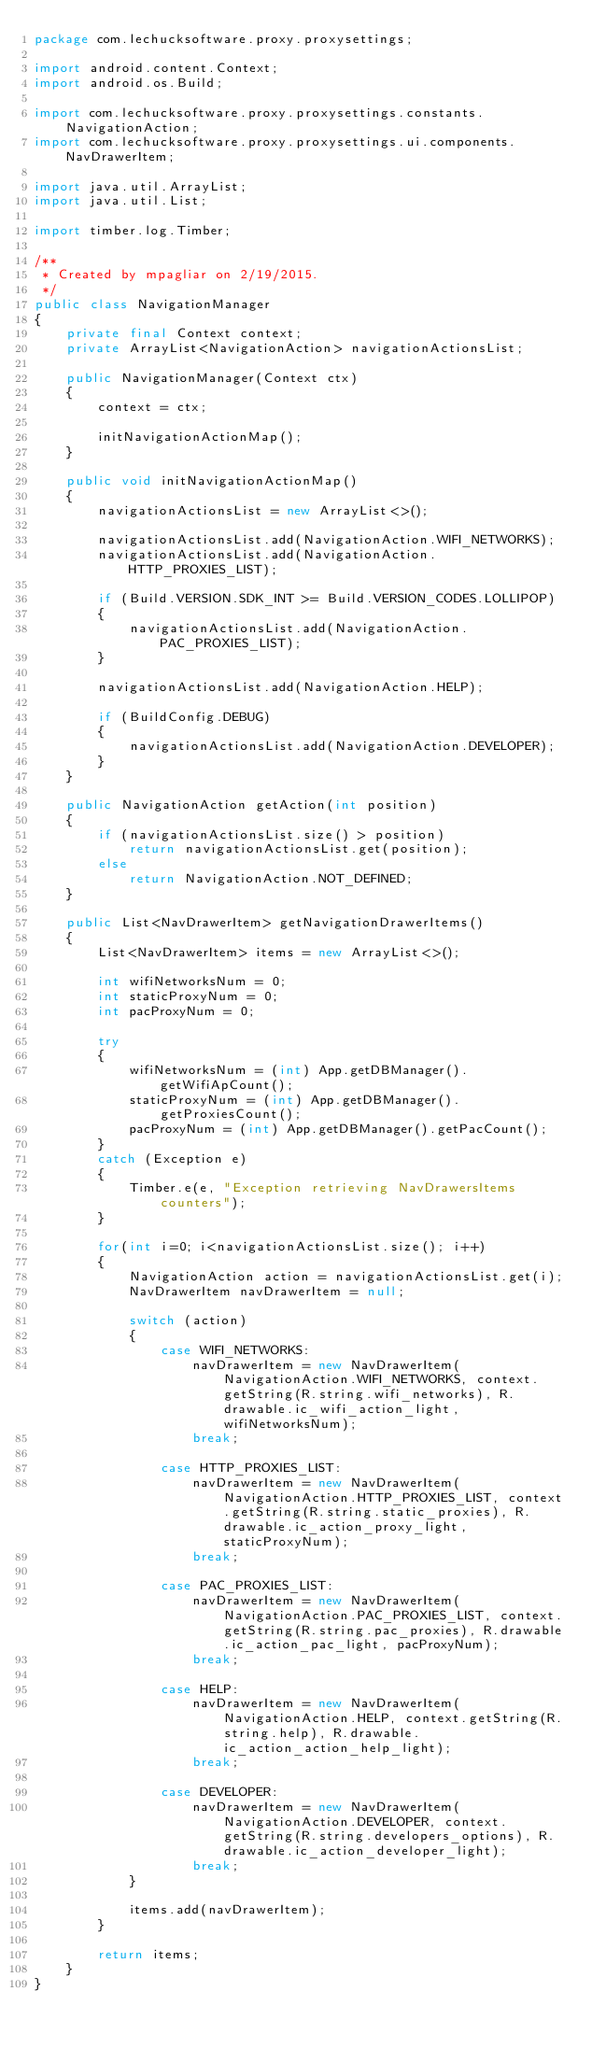<code> <loc_0><loc_0><loc_500><loc_500><_Java_>package com.lechucksoftware.proxy.proxysettings;

import android.content.Context;
import android.os.Build;

import com.lechucksoftware.proxy.proxysettings.constants.NavigationAction;
import com.lechucksoftware.proxy.proxysettings.ui.components.NavDrawerItem;

import java.util.ArrayList;
import java.util.List;

import timber.log.Timber;

/**
 * Created by mpagliar on 2/19/2015.
 */
public class NavigationManager
{
    private final Context context;
    private ArrayList<NavigationAction> navigationActionsList;

    public NavigationManager(Context ctx)
    {
        context = ctx;

        initNavigationActionMap();
    }

    public void initNavigationActionMap()
    {
        navigationActionsList = new ArrayList<>();

        navigationActionsList.add(NavigationAction.WIFI_NETWORKS);
        navigationActionsList.add(NavigationAction.HTTP_PROXIES_LIST);

        if (Build.VERSION.SDK_INT >= Build.VERSION_CODES.LOLLIPOP)
        {
            navigationActionsList.add(NavigationAction.PAC_PROXIES_LIST);
        }

        navigationActionsList.add(NavigationAction.HELP);

        if (BuildConfig.DEBUG)
        {
            navigationActionsList.add(NavigationAction.DEVELOPER);
        }
    }

    public NavigationAction getAction(int position)
    {
        if (navigationActionsList.size() > position)
            return navigationActionsList.get(position);
        else
            return NavigationAction.NOT_DEFINED;
    }

    public List<NavDrawerItem> getNavigationDrawerItems()
    {
        List<NavDrawerItem> items = new ArrayList<>();

        int wifiNetworksNum = 0;
        int staticProxyNum = 0;
        int pacProxyNum = 0;

        try
        {
            wifiNetworksNum = (int) App.getDBManager().getWifiApCount();
            staticProxyNum = (int) App.getDBManager().getProxiesCount();
            pacProxyNum = (int) App.getDBManager().getPacCount();
        }
        catch (Exception e)
        {
            Timber.e(e, "Exception retrieving NavDrawersItems counters");
        }

        for(int i=0; i<navigationActionsList.size(); i++)
        {
            NavigationAction action = navigationActionsList.get(i);
            NavDrawerItem navDrawerItem = null;

            switch (action)
            {
                case WIFI_NETWORKS:
                    navDrawerItem = new NavDrawerItem(NavigationAction.WIFI_NETWORKS, context.getString(R.string.wifi_networks), R.drawable.ic_wifi_action_light, wifiNetworksNum);
                    break;

                case HTTP_PROXIES_LIST:
                    navDrawerItem = new NavDrawerItem(NavigationAction.HTTP_PROXIES_LIST, context.getString(R.string.static_proxies), R.drawable.ic_action_proxy_light, staticProxyNum);
                    break;

                case PAC_PROXIES_LIST:
                    navDrawerItem = new NavDrawerItem(NavigationAction.PAC_PROXIES_LIST, context.getString(R.string.pac_proxies), R.drawable.ic_action_pac_light, pacProxyNum);
                    break;

                case HELP:
                    navDrawerItem = new NavDrawerItem(NavigationAction.HELP, context.getString(R.string.help), R.drawable.ic_action_action_help_light);
                    break;

                case DEVELOPER:
                    navDrawerItem = new NavDrawerItem(NavigationAction.DEVELOPER, context.getString(R.string.developers_options), R.drawable.ic_action_developer_light);
                    break;
            }

            items.add(navDrawerItem);
        }

        return items;
    }
}
</code> 